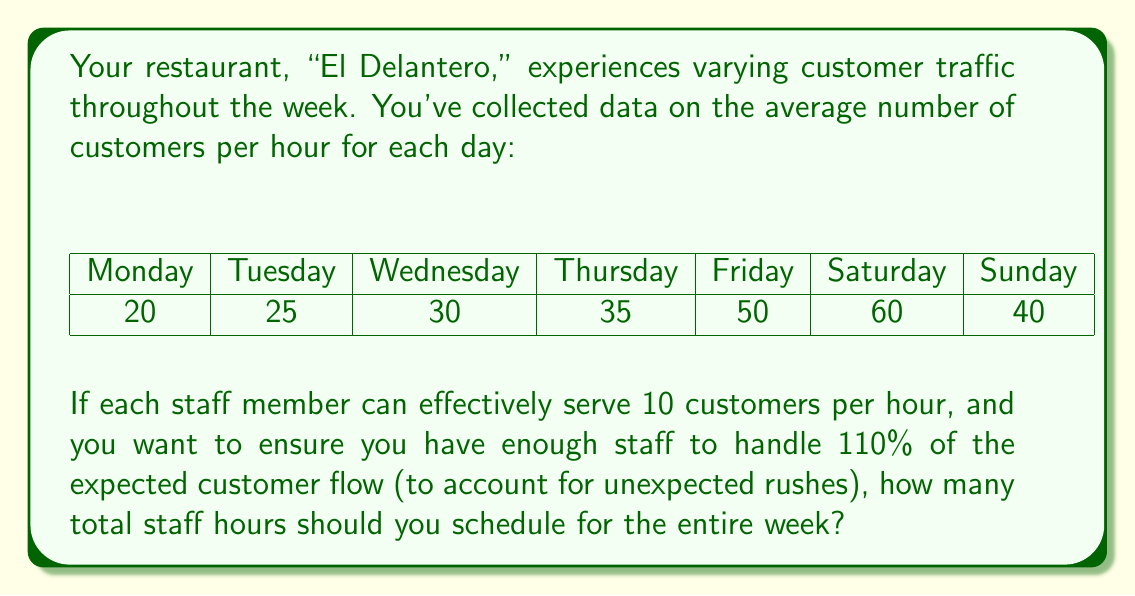What is the answer to this math problem? Let's approach this step-by-step:

1) First, we need to calculate the total number of customers expected per day:
   Monday: 20 * 24 = 480
   Tuesday: 25 * 24 = 600
   Wednesday: 30 * 24 = 720
   Thursday: 35 * 24 = 840
   Friday: 50 * 24 = 1200
   Saturday: 60 * 24 = 1440
   Sunday: 40 * 24 = 960

2) Now, let's sum up the total customers for the week:
   $$ 480 + 600 + 720 + 840 + 1200 + 1440 + 960 = 6240 $$

3) We want to staff for 110% of this amount to account for unexpected rushes:
   $$ 6240 * 1.10 = 6864 $$

4) Each staff member can handle 10 customers per hour, so we divide the total customer count by 10 to get the required staff hours:
   $$ \frac{6864}{10} = 686.4 $$

5) Since we can't schedule partial hours, we round up to the nearest whole number:
   $$ \lceil 686.4 \rceil = 687 $$

Therefore, you should schedule 687 total staff hours for the week.
Answer: 687 hours 